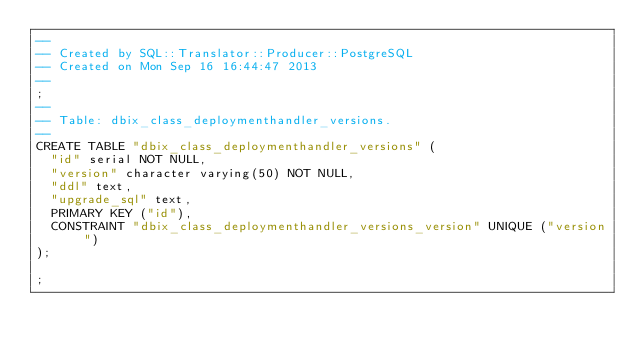<code> <loc_0><loc_0><loc_500><loc_500><_SQL_>-- 
-- Created by SQL::Translator::Producer::PostgreSQL
-- Created on Mon Sep 16 16:44:47 2013
-- 
;
--
-- Table: dbix_class_deploymenthandler_versions.
--
CREATE TABLE "dbix_class_deploymenthandler_versions" (
  "id" serial NOT NULL,
  "version" character varying(50) NOT NULL,
  "ddl" text,
  "upgrade_sql" text,
  PRIMARY KEY ("id"),
  CONSTRAINT "dbix_class_deploymenthandler_versions_version" UNIQUE ("version")
);

;
</code> 